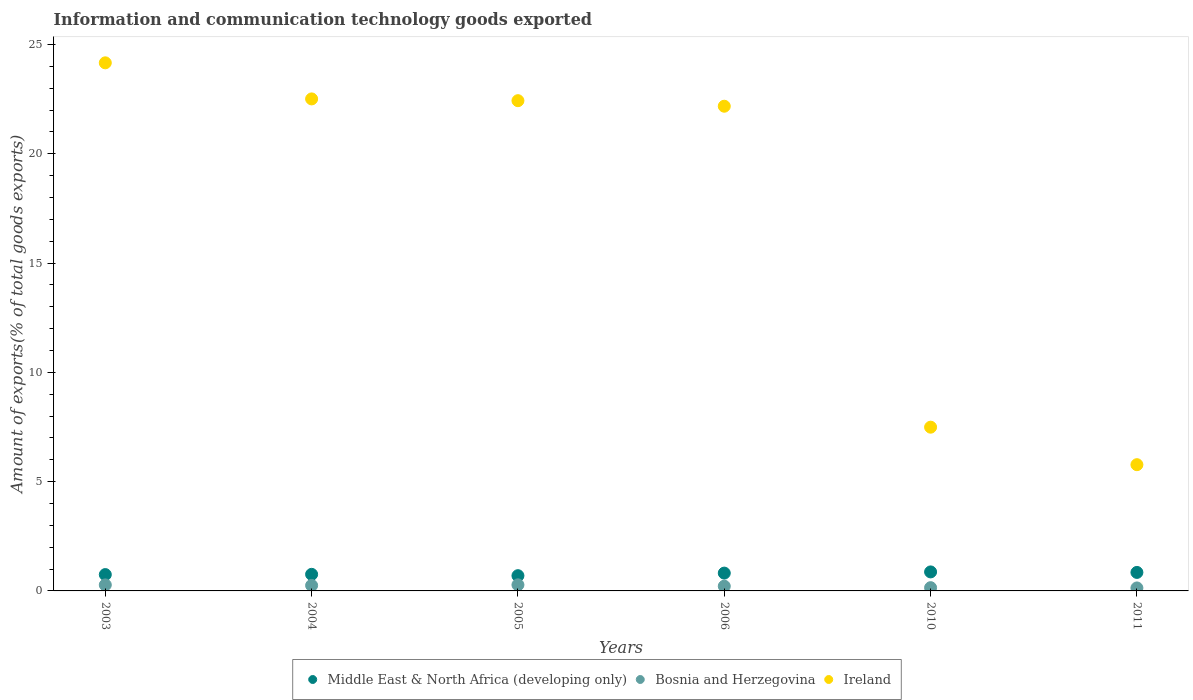How many different coloured dotlines are there?
Make the answer very short. 3. What is the amount of goods exported in Bosnia and Herzegovina in 2004?
Your answer should be compact. 0.25. Across all years, what is the maximum amount of goods exported in Bosnia and Herzegovina?
Make the answer very short. 0.28. Across all years, what is the minimum amount of goods exported in Middle East & North Africa (developing only)?
Your response must be concise. 0.7. In which year was the amount of goods exported in Middle East & North Africa (developing only) maximum?
Your response must be concise. 2010. What is the total amount of goods exported in Ireland in the graph?
Make the answer very short. 104.55. What is the difference between the amount of goods exported in Middle East & North Africa (developing only) in 2004 and that in 2011?
Your answer should be compact. -0.09. What is the difference between the amount of goods exported in Bosnia and Herzegovina in 2003 and the amount of goods exported in Ireland in 2010?
Make the answer very short. -7.22. What is the average amount of goods exported in Ireland per year?
Give a very brief answer. 17.43. In the year 2004, what is the difference between the amount of goods exported in Middle East & North Africa (developing only) and amount of goods exported in Ireland?
Offer a very short reply. -21.75. What is the ratio of the amount of goods exported in Middle East & North Africa (developing only) in 2004 to that in 2005?
Offer a terse response. 1.09. Is the difference between the amount of goods exported in Middle East & North Africa (developing only) in 2004 and 2011 greater than the difference between the amount of goods exported in Ireland in 2004 and 2011?
Keep it short and to the point. No. What is the difference between the highest and the second highest amount of goods exported in Middle East & North Africa (developing only)?
Provide a short and direct response. 0.02. What is the difference between the highest and the lowest amount of goods exported in Ireland?
Your answer should be very brief. 18.39. In how many years, is the amount of goods exported in Bosnia and Herzegovina greater than the average amount of goods exported in Bosnia and Herzegovina taken over all years?
Keep it short and to the point. 3. Is the sum of the amount of goods exported in Middle East & North Africa (developing only) in 2004 and 2010 greater than the maximum amount of goods exported in Bosnia and Herzegovina across all years?
Offer a terse response. Yes. Is it the case that in every year, the sum of the amount of goods exported in Middle East & North Africa (developing only) and amount of goods exported in Ireland  is greater than the amount of goods exported in Bosnia and Herzegovina?
Give a very brief answer. Yes. Is the amount of goods exported in Middle East & North Africa (developing only) strictly less than the amount of goods exported in Ireland over the years?
Provide a succinct answer. Yes. Are the values on the major ticks of Y-axis written in scientific E-notation?
Provide a succinct answer. No. Does the graph contain grids?
Your answer should be very brief. No. Where does the legend appear in the graph?
Give a very brief answer. Bottom center. How many legend labels are there?
Make the answer very short. 3. What is the title of the graph?
Your response must be concise. Information and communication technology goods exported. Does "El Salvador" appear as one of the legend labels in the graph?
Keep it short and to the point. No. What is the label or title of the X-axis?
Your answer should be compact. Years. What is the label or title of the Y-axis?
Offer a very short reply. Amount of exports(% of total goods exports). What is the Amount of exports(% of total goods exports) of Middle East & North Africa (developing only) in 2003?
Provide a short and direct response. 0.75. What is the Amount of exports(% of total goods exports) of Bosnia and Herzegovina in 2003?
Provide a short and direct response. 0.28. What is the Amount of exports(% of total goods exports) of Ireland in 2003?
Your answer should be compact. 24.16. What is the Amount of exports(% of total goods exports) of Middle East & North Africa (developing only) in 2004?
Provide a succinct answer. 0.76. What is the Amount of exports(% of total goods exports) in Bosnia and Herzegovina in 2004?
Your answer should be compact. 0.25. What is the Amount of exports(% of total goods exports) in Ireland in 2004?
Ensure brevity in your answer.  22.51. What is the Amount of exports(% of total goods exports) of Middle East & North Africa (developing only) in 2005?
Provide a succinct answer. 0.7. What is the Amount of exports(% of total goods exports) of Bosnia and Herzegovina in 2005?
Make the answer very short. 0.28. What is the Amount of exports(% of total goods exports) of Ireland in 2005?
Your response must be concise. 22.43. What is the Amount of exports(% of total goods exports) in Middle East & North Africa (developing only) in 2006?
Provide a succinct answer. 0.82. What is the Amount of exports(% of total goods exports) of Bosnia and Herzegovina in 2006?
Offer a very short reply. 0.22. What is the Amount of exports(% of total goods exports) of Ireland in 2006?
Provide a short and direct response. 22.18. What is the Amount of exports(% of total goods exports) in Middle East & North Africa (developing only) in 2010?
Your answer should be very brief. 0.87. What is the Amount of exports(% of total goods exports) of Bosnia and Herzegovina in 2010?
Provide a succinct answer. 0.15. What is the Amount of exports(% of total goods exports) of Ireland in 2010?
Give a very brief answer. 7.49. What is the Amount of exports(% of total goods exports) in Middle East & North Africa (developing only) in 2011?
Provide a short and direct response. 0.85. What is the Amount of exports(% of total goods exports) in Bosnia and Herzegovina in 2011?
Your answer should be compact. 0.14. What is the Amount of exports(% of total goods exports) of Ireland in 2011?
Offer a very short reply. 5.78. Across all years, what is the maximum Amount of exports(% of total goods exports) of Middle East & North Africa (developing only)?
Keep it short and to the point. 0.87. Across all years, what is the maximum Amount of exports(% of total goods exports) of Bosnia and Herzegovina?
Give a very brief answer. 0.28. Across all years, what is the maximum Amount of exports(% of total goods exports) of Ireland?
Ensure brevity in your answer.  24.16. Across all years, what is the minimum Amount of exports(% of total goods exports) of Middle East & North Africa (developing only)?
Your answer should be compact. 0.7. Across all years, what is the minimum Amount of exports(% of total goods exports) of Bosnia and Herzegovina?
Your answer should be compact. 0.14. Across all years, what is the minimum Amount of exports(% of total goods exports) of Ireland?
Your answer should be compact. 5.78. What is the total Amount of exports(% of total goods exports) in Middle East & North Africa (developing only) in the graph?
Offer a terse response. 4.74. What is the total Amount of exports(% of total goods exports) in Bosnia and Herzegovina in the graph?
Provide a short and direct response. 1.3. What is the total Amount of exports(% of total goods exports) of Ireland in the graph?
Your response must be concise. 104.55. What is the difference between the Amount of exports(% of total goods exports) of Middle East & North Africa (developing only) in 2003 and that in 2004?
Offer a very short reply. -0.01. What is the difference between the Amount of exports(% of total goods exports) of Bosnia and Herzegovina in 2003 and that in 2004?
Ensure brevity in your answer.  0.03. What is the difference between the Amount of exports(% of total goods exports) of Ireland in 2003 and that in 2004?
Your response must be concise. 1.65. What is the difference between the Amount of exports(% of total goods exports) of Bosnia and Herzegovina in 2003 and that in 2005?
Give a very brief answer. -0. What is the difference between the Amount of exports(% of total goods exports) in Ireland in 2003 and that in 2005?
Provide a short and direct response. 1.73. What is the difference between the Amount of exports(% of total goods exports) of Middle East & North Africa (developing only) in 2003 and that in 2006?
Offer a very short reply. -0.07. What is the difference between the Amount of exports(% of total goods exports) of Bosnia and Herzegovina in 2003 and that in 2006?
Your answer should be compact. 0.06. What is the difference between the Amount of exports(% of total goods exports) of Ireland in 2003 and that in 2006?
Make the answer very short. 1.99. What is the difference between the Amount of exports(% of total goods exports) in Middle East & North Africa (developing only) in 2003 and that in 2010?
Make the answer very short. -0.12. What is the difference between the Amount of exports(% of total goods exports) of Bosnia and Herzegovina in 2003 and that in 2010?
Ensure brevity in your answer.  0.13. What is the difference between the Amount of exports(% of total goods exports) of Ireland in 2003 and that in 2010?
Your answer should be compact. 16.67. What is the difference between the Amount of exports(% of total goods exports) of Middle East & North Africa (developing only) in 2003 and that in 2011?
Give a very brief answer. -0.1. What is the difference between the Amount of exports(% of total goods exports) in Bosnia and Herzegovina in 2003 and that in 2011?
Give a very brief answer. 0.14. What is the difference between the Amount of exports(% of total goods exports) of Ireland in 2003 and that in 2011?
Provide a succinct answer. 18.39. What is the difference between the Amount of exports(% of total goods exports) in Middle East & North Africa (developing only) in 2004 and that in 2005?
Keep it short and to the point. 0.06. What is the difference between the Amount of exports(% of total goods exports) of Bosnia and Herzegovina in 2004 and that in 2005?
Give a very brief answer. -0.03. What is the difference between the Amount of exports(% of total goods exports) of Ireland in 2004 and that in 2005?
Your answer should be very brief. 0.08. What is the difference between the Amount of exports(% of total goods exports) in Middle East & North Africa (developing only) in 2004 and that in 2006?
Offer a terse response. -0.06. What is the difference between the Amount of exports(% of total goods exports) in Bosnia and Herzegovina in 2004 and that in 2006?
Keep it short and to the point. 0.03. What is the difference between the Amount of exports(% of total goods exports) of Ireland in 2004 and that in 2006?
Ensure brevity in your answer.  0.33. What is the difference between the Amount of exports(% of total goods exports) in Middle East & North Africa (developing only) in 2004 and that in 2010?
Give a very brief answer. -0.11. What is the difference between the Amount of exports(% of total goods exports) in Bosnia and Herzegovina in 2004 and that in 2010?
Provide a succinct answer. 0.1. What is the difference between the Amount of exports(% of total goods exports) in Ireland in 2004 and that in 2010?
Provide a succinct answer. 15.02. What is the difference between the Amount of exports(% of total goods exports) of Middle East & North Africa (developing only) in 2004 and that in 2011?
Provide a short and direct response. -0.09. What is the difference between the Amount of exports(% of total goods exports) of Bosnia and Herzegovina in 2004 and that in 2011?
Keep it short and to the point. 0.11. What is the difference between the Amount of exports(% of total goods exports) in Ireland in 2004 and that in 2011?
Offer a terse response. 16.74. What is the difference between the Amount of exports(% of total goods exports) in Middle East & North Africa (developing only) in 2005 and that in 2006?
Offer a very short reply. -0.12. What is the difference between the Amount of exports(% of total goods exports) in Bosnia and Herzegovina in 2005 and that in 2006?
Provide a succinct answer. 0.06. What is the difference between the Amount of exports(% of total goods exports) of Ireland in 2005 and that in 2006?
Offer a very short reply. 0.25. What is the difference between the Amount of exports(% of total goods exports) in Middle East & North Africa (developing only) in 2005 and that in 2010?
Provide a short and direct response. -0.17. What is the difference between the Amount of exports(% of total goods exports) in Bosnia and Herzegovina in 2005 and that in 2010?
Ensure brevity in your answer.  0.13. What is the difference between the Amount of exports(% of total goods exports) in Ireland in 2005 and that in 2010?
Provide a short and direct response. 14.94. What is the difference between the Amount of exports(% of total goods exports) of Middle East & North Africa (developing only) in 2005 and that in 2011?
Keep it short and to the point. -0.15. What is the difference between the Amount of exports(% of total goods exports) of Bosnia and Herzegovina in 2005 and that in 2011?
Provide a succinct answer. 0.14. What is the difference between the Amount of exports(% of total goods exports) of Ireland in 2005 and that in 2011?
Give a very brief answer. 16.65. What is the difference between the Amount of exports(% of total goods exports) in Middle East & North Africa (developing only) in 2006 and that in 2010?
Give a very brief answer. -0.05. What is the difference between the Amount of exports(% of total goods exports) in Bosnia and Herzegovina in 2006 and that in 2010?
Offer a terse response. 0.07. What is the difference between the Amount of exports(% of total goods exports) in Ireland in 2006 and that in 2010?
Your answer should be very brief. 14.69. What is the difference between the Amount of exports(% of total goods exports) in Middle East & North Africa (developing only) in 2006 and that in 2011?
Your answer should be very brief. -0.03. What is the difference between the Amount of exports(% of total goods exports) in Bosnia and Herzegovina in 2006 and that in 2011?
Keep it short and to the point. 0.08. What is the difference between the Amount of exports(% of total goods exports) of Ireland in 2006 and that in 2011?
Give a very brief answer. 16.4. What is the difference between the Amount of exports(% of total goods exports) of Middle East & North Africa (developing only) in 2010 and that in 2011?
Your answer should be very brief. 0.02. What is the difference between the Amount of exports(% of total goods exports) in Bosnia and Herzegovina in 2010 and that in 2011?
Ensure brevity in your answer.  0.01. What is the difference between the Amount of exports(% of total goods exports) in Ireland in 2010 and that in 2011?
Your response must be concise. 1.72. What is the difference between the Amount of exports(% of total goods exports) in Middle East & North Africa (developing only) in 2003 and the Amount of exports(% of total goods exports) in Bosnia and Herzegovina in 2004?
Offer a very short reply. 0.5. What is the difference between the Amount of exports(% of total goods exports) in Middle East & North Africa (developing only) in 2003 and the Amount of exports(% of total goods exports) in Ireland in 2004?
Your response must be concise. -21.76. What is the difference between the Amount of exports(% of total goods exports) in Bosnia and Herzegovina in 2003 and the Amount of exports(% of total goods exports) in Ireland in 2004?
Provide a succinct answer. -22.24. What is the difference between the Amount of exports(% of total goods exports) of Middle East & North Africa (developing only) in 2003 and the Amount of exports(% of total goods exports) of Bosnia and Herzegovina in 2005?
Your response must be concise. 0.47. What is the difference between the Amount of exports(% of total goods exports) of Middle East & North Africa (developing only) in 2003 and the Amount of exports(% of total goods exports) of Ireland in 2005?
Provide a short and direct response. -21.68. What is the difference between the Amount of exports(% of total goods exports) in Bosnia and Herzegovina in 2003 and the Amount of exports(% of total goods exports) in Ireland in 2005?
Make the answer very short. -22.16. What is the difference between the Amount of exports(% of total goods exports) of Middle East & North Africa (developing only) in 2003 and the Amount of exports(% of total goods exports) of Bosnia and Herzegovina in 2006?
Your answer should be compact. 0.53. What is the difference between the Amount of exports(% of total goods exports) in Middle East & North Africa (developing only) in 2003 and the Amount of exports(% of total goods exports) in Ireland in 2006?
Keep it short and to the point. -21.43. What is the difference between the Amount of exports(% of total goods exports) in Bosnia and Herzegovina in 2003 and the Amount of exports(% of total goods exports) in Ireland in 2006?
Provide a short and direct response. -21.9. What is the difference between the Amount of exports(% of total goods exports) of Middle East & North Africa (developing only) in 2003 and the Amount of exports(% of total goods exports) of Bosnia and Herzegovina in 2010?
Your response must be concise. 0.6. What is the difference between the Amount of exports(% of total goods exports) in Middle East & North Africa (developing only) in 2003 and the Amount of exports(% of total goods exports) in Ireland in 2010?
Ensure brevity in your answer.  -6.74. What is the difference between the Amount of exports(% of total goods exports) in Bosnia and Herzegovina in 2003 and the Amount of exports(% of total goods exports) in Ireland in 2010?
Ensure brevity in your answer.  -7.22. What is the difference between the Amount of exports(% of total goods exports) of Middle East & North Africa (developing only) in 2003 and the Amount of exports(% of total goods exports) of Bosnia and Herzegovina in 2011?
Your answer should be compact. 0.61. What is the difference between the Amount of exports(% of total goods exports) of Middle East & North Africa (developing only) in 2003 and the Amount of exports(% of total goods exports) of Ireland in 2011?
Keep it short and to the point. -5.03. What is the difference between the Amount of exports(% of total goods exports) in Bosnia and Herzegovina in 2003 and the Amount of exports(% of total goods exports) in Ireland in 2011?
Your answer should be very brief. -5.5. What is the difference between the Amount of exports(% of total goods exports) of Middle East & North Africa (developing only) in 2004 and the Amount of exports(% of total goods exports) of Bosnia and Herzegovina in 2005?
Provide a succinct answer. 0.48. What is the difference between the Amount of exports(% of total goods exports) in Middle East & North Africa (developing only) in 2004 and the Amount of exports(% of total goods exports) in Ireland in 2005?
Your answer should be compact. -21.67. What is the difference between the Amount of exports(% of total goods exports) in Bosnia and Herzegovina in 2004 and the Amount of exports(% of total goods exports) in Ireland in 2005?
Offer a very short reply. -22.18. What is the difference between the Amount of exports(% of total goods exports) in Middle East & North Africa (developing only) in 2004 and the Amount of exports(% of total goods exports) in Bosnia and Herzegovina in 2006?
Offer a terse response. 0.54. What is the difference between the Amount of exports(% of total goods exports) of Middle East & North Africa (developing only) in 2004 and the Amount of exports(% of total goods exports) of Ireland in 2006?
Provide a short and direct response. -21.42. What is the difference between the Amount of exports(% of total goods exports) in Bosnia and Herzegovina in 2004 and the Amount of exports(% of total goods exports) in Ireland in 2006?
Offer a terse response. -21.93. What is the difference between the Amount of exports(% of total goods exports) of Middle East & North Africa (developing only) in 2004 and the Amount of exports(% of total goods exports) of Bosnia and Herzegovina in 2010?
Give a very brief answer. 0.61. What is the difference between the Amount of exports(% of total goods exports) in Middle East & North Africa (developing only) in 2004 and the Amount of exports(% of total goods exports) in Ireland in 2010?
Offer a very short reply. -6.73. What is the difference between the Amount of exports(% of total goods exports) in Bosnia and Herzegovina in 2004 and the Amount of exports(% of total goods exports) in Ireland in 2010?
Your answer should be compact. -7.24. What is the difference between the Amount of exports(% of total goods exports) of Middle East & North Africa (developing only) in 2004 and the Amount of exports(% of total goods exports) of Bosnia and Herzegovina in 2011?
Offer a terse response. 0.62. What is the difference between the Amount of exports(% of total goods exports) in Middle East & North Africa (developing only) in 2004 and the Amount of exports(% of total goods exports) in Ireland in 2011?
Make the answer very short. -5.02. What is the difference between the Amount of exports(% of total goods exports) in Bosnia and Herzegovina in 2004 and the Amount of exports(% of total goods exports) in Ireland in 2011?
Keep it short and to the point. -5.53. What is the difference between the Amount of exports(% of total goods exports) of Middle East & North Africa (developing only) in 2005 and the Amount of exports(% of total goods exports) of Bosnia and Herzegovina in 2006?
Ensure brevity in your answer.  0.48. What is the difference between the Amount of exports(% of total goods exports) of Middle East & North Africa (developing only) in 2005 and the Amount of exports(% of total goods exports) of Ireland in 2006?
Give a very brief answer. -21.48. What is the difference between the Amount of exports(% of total goods exports) in Bosnia and Herzegovina in 2005 and the Amount of exports(% of total goods exports) in Ireland in 2006?
Give a very brief answer. -21.9. What is the difference between the Amount of exports(% of total goods exports) in Middle East & North Africa (developing only) in 2005 and the Amount of exports(% of total goods exports) in Bosnia and Herzegovina in 2010?
Give a very brief answer. 0.55. What is the difference between the Amount of exports(% of total goods exports) in Middle East & North Africa (developing only) in 2005 and the Amount of exports(% of total goods exports) in Ireland in 2010?
Ensure brevity in your answer.  -6.79. What is the difference between the Amount of exports(% of total goods exports) of Bosnia and Herzegovina in 2005 and the Amount of exports(% of total goods exports) of Ireland in 2010?
Your answer should be compact. -7.21. What is the difference between the Amount of exports(% of total goods exports) of Middle East & North Africa (developing only) in 2005 and the Amount of exports(% of total goods exports) of Bosnia and Herzegovina in 2011?
Your response must be concise. 0.56. What is the difference between the Amount of exports(% of total goods exports) of Middle East & North Africa (developing only) in 2005 and the Amount of exports(% of total goods exports) of Ireland in 2011?
Your answer should be very brief. -5.08. What is the difference between the Amount of exports(% of total goods exports) in Bosnia and Herzegovina in 2005 and the Amount of exports(% of total goods exports) in Ireland in 2011?
Your response must be concise. -5.5. What is the difference between the Amount of exports(% of total goods exports) of Middle East & North Africa (developing only) in 2006 and the Amount of exports(% of total goods exports) of Bosnia and Herzegovina in 2010?
Your answer should be very brief. 0.67. What is the difference between the Amount of exports(% of total goods exports) in Middle East & North Africa (developing only) in 2006 and the Amount of exports(% of total goods exports) in Ireland in 2010?
Make the answer very short. -6.68. What is the difference between the Amount of exports(% of total goods exports) of Bosnia and Herzegovina in 2006 and the Amount of exports(% of total goods exports) of Ireland in 2010?
Provide a short and direct response. -7.28. What is the difference between the Amount of exports(% of total goods exports) of Middle East & North Africa (developing only) in 2006 and the Amount of exports(% of total goods exports) of Bosnia and Herzegovina in 2011?
Provide a short and direct response. 0.68. What is the difference between the Amount of exports(% of total goods exports) in Middle East & North Africa (developing only) in 2006 and the Amount of exports(% of total goods exports) in Ireland in 2011?
Your response must be concise. -4.96. What is the difference between the Amount of exports(% of total goods exports) of Bosnia and Herzegovina in 2006 and the Amount of exports(% of total goods exports) of Ireland in 2011?
Keep it short and to the point. -5.56. What is the difference between the Amount of exports(% of total goods exports) in Middle East & North Africa (developing only) in 2010 and the Amount of exports(% of total goods exports) in Bosnia and Herzegovina in 2011?
Your answer should be very brief. 0.73. What is the difference between the Amount of exports(% of total goods exports) of Middle East & North Africa (developing only) in 2010 and the Amount of exports(% of total goods exports) of Ireland in 2011?
Give a very brief answer. -4.91. What is the difference between the Amount of exports(% of total goods exports) of Bosnia and Herzegovina in 2010 and the Amount of exports(% of total goods exports) of Ireland in 2011?
Give a very brief answer. -5.63. What is the average Amount of exports(% of total goods exports) in Middle East & North Africa (developing only) per year?
Offer a very short reply. 0.79. What is the average Amount of exports(% of total goods exports) in Bosnia and Herzegovina per year?
Ensure brevity in your answer.  0.22. What is the average Amount of exports(% of total goods exports) of Ireland per year?
Provide a short and direct response. 17.43. In the year 2003, what is the difference between the Amount of exports(% of total goods exports) of Middle East & North Africa (developing only) and Amount of exports(% of total goods exports) of Bosnia and Herzegovina?
Your answer should be very brief. 0.47. In the year 2003, what is the difference between the Amount of exports(% of total goods exports) of Middle East & North Africa (developing only) and Amount of exports(% of total goods exports) of Ireland?
Give a very brief answer. -23.42. In the year 2003, what is the difference between the Amount of exports(% of total goods exports) in Bosnia and Herzegovina and Amount of exports(% of total goods exports) in Ireland?
Your answer should be very brief. -23.89. In the year 2004, what is the difference between the Amount of exports(% of total goods exports) of Middle East & North Africa (developing only) and Amount of exports(% of total goods exports) of Bosnia and Herzegovina?
Your response must be concise. 0.51. In the year 2004, what is the difference between the Amount of exports(% of total goods exports) of Middle East & North Africa (developing only) and Amount of exports(% of total goods exports) of Ireland?
Your answer should be compact. -21.75. In the year 2004, what is the difference between the Amount of exports(% of total goods exports) of Bosnia and Herzegovina and Amount of exports(% of total goods exports) of Ireland?
Offer a terse response. -22.26. In the year 2005, what is the difference between the Amount of exports(% of total goods exports) of Middle East & North Africa (developing only) and Amount of exports(% of total goods exports) of Bosnia and Herzegovina?
Provide a short and direct response. 0.42. In the year 2005, what is the difference between the Amount of exports(% of total goods exports) in Middle East & North Africa (developing only) and Amount of exports(% of total goods exports) in Ireland?
Ensure brevity in your answer.  -21.73. In the year 2005, what is the difference between the Amount of exports(% of total goods exports) in Bosnia and Herzegovina and Amount of exports(% of total goods exports) in Ireland?
Make the answer very short. -22.15. In the year 2006, what is the difference between the Amount of exports(% of total goods exports) of Middle East & North Africa (developing only) and Amount of exports(% of total goods exports) of Bosnia and Herzegovina?
Ensure brevity in your answer.  0.6. In the year 2006, what is the difference between the Amount of exports(% of total goods exports) in Middle East & North Africa (developing only) and Amount of exports(% of total goods exports) in Ireland?
Your response must be concise. -21.36. In the year 2006, what is the difference between the Amount of exports(% of total goods exports) of Bosnia and Herzegovina and Amount of exports(% of total goods exports) of Ireland?
Your answer should be compact. -21.96. In the year 2010, what is the difference between the Amount of exports(% of total goods exports) of Middle East & North Africa (developing only) and Amount of exports(% of total goods exports) of Bosnia and Herzegovina?
Ensure brevity in your answer.  0.72. In the year 2010, what is the difference between the Amount of exports(% of total goods exports) in Middle East & North Africa (developing only) and Amount of exports(% of total goods exports) in Ireland?
Offer a terse response. -6.62. In the year 2010, what is the difference between the Amount of exports(% of total goods exports) in Bosnia and Herzegovina and Amount of exports(% of total goods exports) in Ireland?
Give a very brief answer. -7.34. In the year 2011, what is the difference between the Amount of exports(% of total goods exports) in Middle East & North Africa (developing only) and Amount of exports(% of total goods exports) in Bosnia and Herzegovina?
Your answer should be very brief. 0.71. In the year 2011, what is the difference between the Amount of exports(% of total goods exports) of Middle East & North Africa (developing only) and Amount of exports(% of total goods exports) of Ireland?
Give a very brief answer. -4.93. In the year 2011, what is the difference between the Amount of exports(% of total goods exports) of Bosnia and Herzegovina and Amount of exports(% of total goods exports) of Ireland?
Give a very brief answer. -5.64. What is the ratio of the Amount of exports(% of total goods exports) in Middle East & North Africa (developing only) in 2003 to that in 2004?
Your answer should be very brief. 0.98. What is the ratio of the Amount of exports(% of total goods exports) in Bosnia and Herzegovina in 2003 to that in 2004?
Offer a very short reply. 1.1. What is the ratio of the Amount of exports(% of total goods exports) in Ireland in 2003 to that in 2004?
Your answer should be very brief. 1.07. What is the ratio of the Amount of exports(% of total goods exports) of Middle East & North Africa (developing only) in 2003 to that in 2005?
Provide a succinct answer. 1.07. What is the ratio of the Amount of exports(% of total goods exports) of Ireland in 2003 to that in 2005?
Offer a very short reply. 1.08. What is the ratio of the Amount of exports(% of total goods exports) of Middle East & North Africa (developing only) in 2003 to that in 2006?
Provide a succinct answer. 0.92. What is the ratio of the Amount of exports(% of total goods exports) of Bosnia and Herzegovina in 2003 to that in 2006?
Provide a succinct answer. 1.28. What is the ratio of the Amount of exports(% of total goods exports) in Ireland in 2003 to that in 2006?
Your answer should be very brief. 1.09. What is the ratio of the Amount of exports(% of total goods exports) of Middle East & North Africa (developing only) in 2003 to that in 2010?
Your answer should be compact. 0.86. What is the ratio of the Amount of exports(% of total goods exports) of Bosnia and Herzegovina in 2003 to that in 2010?
Your answer should be compact. 1.85. What is the ratio of the Amount of exports(% of total goods exports) of Ireland in 2003 to that in 2010?
Keep it short and to the point. 3.23. What is the ratio of the Amount of exports(% of total goods exports) in Middle East & North Africa (developing only) in 2003 to that in 2011?
Ensure brevity in your answer.  0.88. What is the ratio of the Amount of exports(% of total goods exports) of Bosnia and Herzegovina in 2003 to that in 2011?
Your answer should be compact. 2.02. What is the ratio of the Amount of exports(% of total goods exports) in Ireland in 2003 to that in 2011?
Keep it short and to the point. 4.18. What is the ratio of the Amount of exports(% of total goods exports) of Middle East & North Africa (developing only) in 2004 to that in 2005?
Your answer should be compact. 1.09. What is the ratio of the Amount of exports(% of total goods exports) in Bosnia and Herzegovina in 2004 to that in 2005?
Provide a succinct answer. 0.9. What is the ratio of the Amount of exports(% of total goods exports) of Ireland in 2004 to that in 2005?
Provide a short and direct response. 1. What is the ratio of the Amount of exports(% of total goods exports) in Bosnia and Herzegovina in 2004 to that in 2006?
Your response must be concise. 1.16. What is the ratio of the Amount of exports(% of total goods exports) of Ireland in 2004 to that in 2006?
Offer a very short reply. 1.02. What is the ratio of the Amount of exports(% of total goods exports) of Middle East & North Africa (developing only) in 2004 to that in 2010?
Give a very brief answer. 0.87. What is the ratio of the Amount of exports(% of total goods exports) in Bosnia and Herzegovina in 2004 to that in 2010?
Give a very brief answer. 1.69. What is the ratio of the Amount of exports(% of total goods exports) of Ireland in 2004 to that in 2010?
Ensure brevity in your answer.  3. What is the ratio of the Amount of exports(% of total goods exports) of Middle East & North Africa (developing only) in 2004 to that in 2011?
Ensure brevity in your answer.  0.9. What is the ratio of the Amount of exports(% of total goods exports) of Bosnia and Herzegovina in 2004 to that in 2011?
Keep it short and to the point. 1.84. What is the ratio of the Amount of exports(% of total goods exports) of Ireland in 2004 to that in 2011?
Make the answer very short. 3.9. What is the ratio of the Amount of exports(% of total goods exports) in Middle East & North Africa (developing only) in 2005 to that in 2006?
Your answer should be compact. 0.86. What is the ratio of the Amount of exports(% of total goods exports) in Bosnia and Herzegovina in 2005 to that in 2006?
Your answer should be very brief. 1.29. What is the ratio of the Amount of exports(% of total goods exports) in Ireland in 2005 to that in 2006?
Your response must be concise. 1.01. What is the ratio of the Amount of exports(% of total goods exports) in Middle East & North Africa (developing only) in 2005 to that in 2010?
Provide a short and direct response. 0.8. What is the ratio of the Amount of exports(% of total goods exports) of Bosnia and Herzegovina in 2005 to that in 2010?
Make the answer very short. 1.87. What is the ratio of the Amount of exports(% of total goods exports) of Ireland in 2005 to that in 2010?
Provide a succinct answer. 2.99. What is the ratio of the Amount of exports(% of total goods exports) in Middle East & North Africa (developing only) in 2005 to that in 2011?
Your answer should be very brief. 0.82. What is the ratio of the Amount of exports(% of total goods exports) in Bosnia and Herzegovina in 2005 to that in 2011?
Offer a very short reply. 2.04. What is the ratio of the Amount of exports(% of total goods exports) in Ireland in 2005 to that in 2011?
Your response must be concise. 3.88. What is the ratio of the Amount of exports(% of total goods exports) in Middle East & North Africa (developing only) in 2006 to that in 2010?
Provide a succinct answer. 0.94. What is the ratio of the Amount of exports(% of total goods exports) in Bosnia and Herzegovina in 2006 to that in 2010?
Offer a terse response. 1.45. What is the ratio of the Amount of exports(% of total goods exports) of Ireland in 2006 to that in 2010?
Offer a very short reply. 2.96. What is the ratio of the Amount of exports(% of total goods exports) of Bosnia and Herzegovina in 2006 to that in 2011?
Make the answer very short. 1.58. What is the ratio of the Amount of exports(% of total goods exports) of Ireland in 2006 to that in 2011?
Make the answer very short. 3.84. What is the ratio of the Amount of exports(% of total goods exports) in Middle East & North Africa (developing only) in 2010 to that in 2011?
Make the answer very short. 1.03. What is the ratio of the Amount of exports(% of total goods exports) in Bosnia and Herzegovina in 2010 to that in 2011?
Your answer should be compact. 1.09. What is the ratio of the Amount of exports(% of total goods exports) in Ireland in 2010 to that in 2011?
Your answer should be compact. 1.3. What is the difference between the highest and the second highest Amount of exports(% of total goods exports) of Middle East & North Africa (developing only)?
Your answer should be compact. 0.02. What is the difference between the highest and the second highest Amount of exports(% of total goods exports) of Bosnia and Herzegovina?
Offer a very short reply. 0. What is the difference between the highest and the second highest Amount of exports(% of total goods exports) of Ireland?
Provide a short and direct response. 1.65. What is the difference between the highest and the lowest Amount of exports(% of total goods exports) in Middle East & North Africa (developing only)?
Offer a very short reply. 0.17. What is the difference between the highest and the lowest Amount of exports(% of total goods exports) of Bosnia and Herzegovina?
Your answer should be compact. 0.14. What is the difference between the highest and the lowest Amount of exports(% of total goods exports) of Ireland?
Your answer should be very brief. 18.39. 